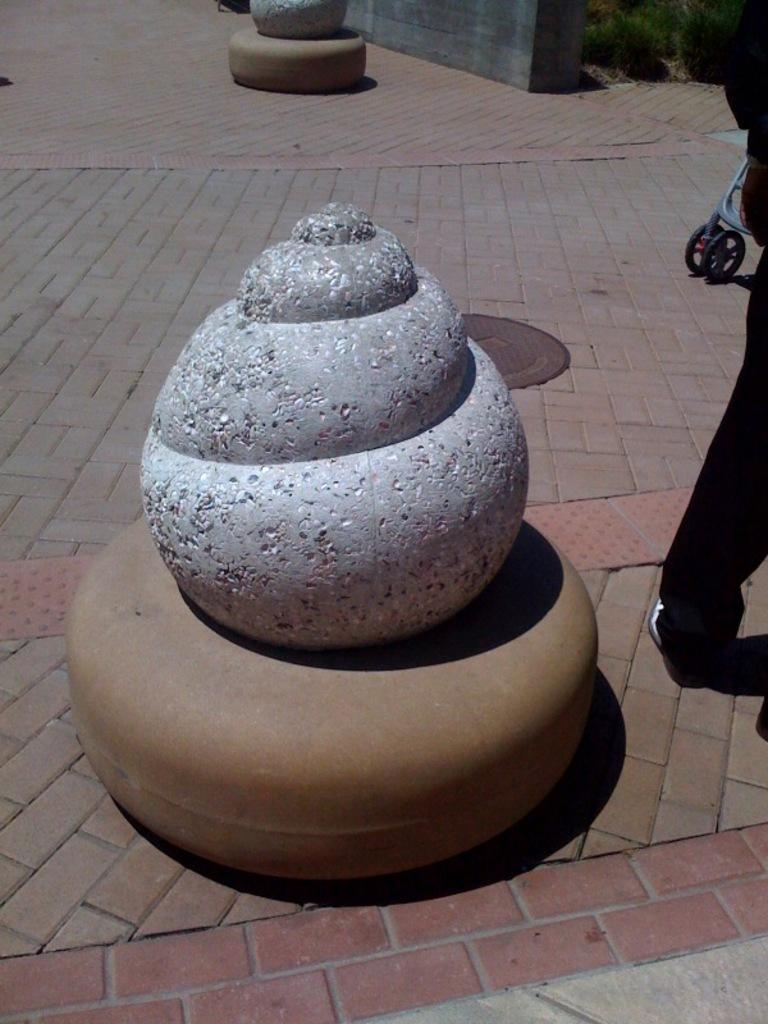What can be seen on the ground in the image? There is a stone on the ground in the image. Can you describe anything else visible in the image? There is a person's leg visible on the right side of the image. What type of produce is being harvested by the person in the image? There is no produce visible in the image, and the person's activity is not described. 